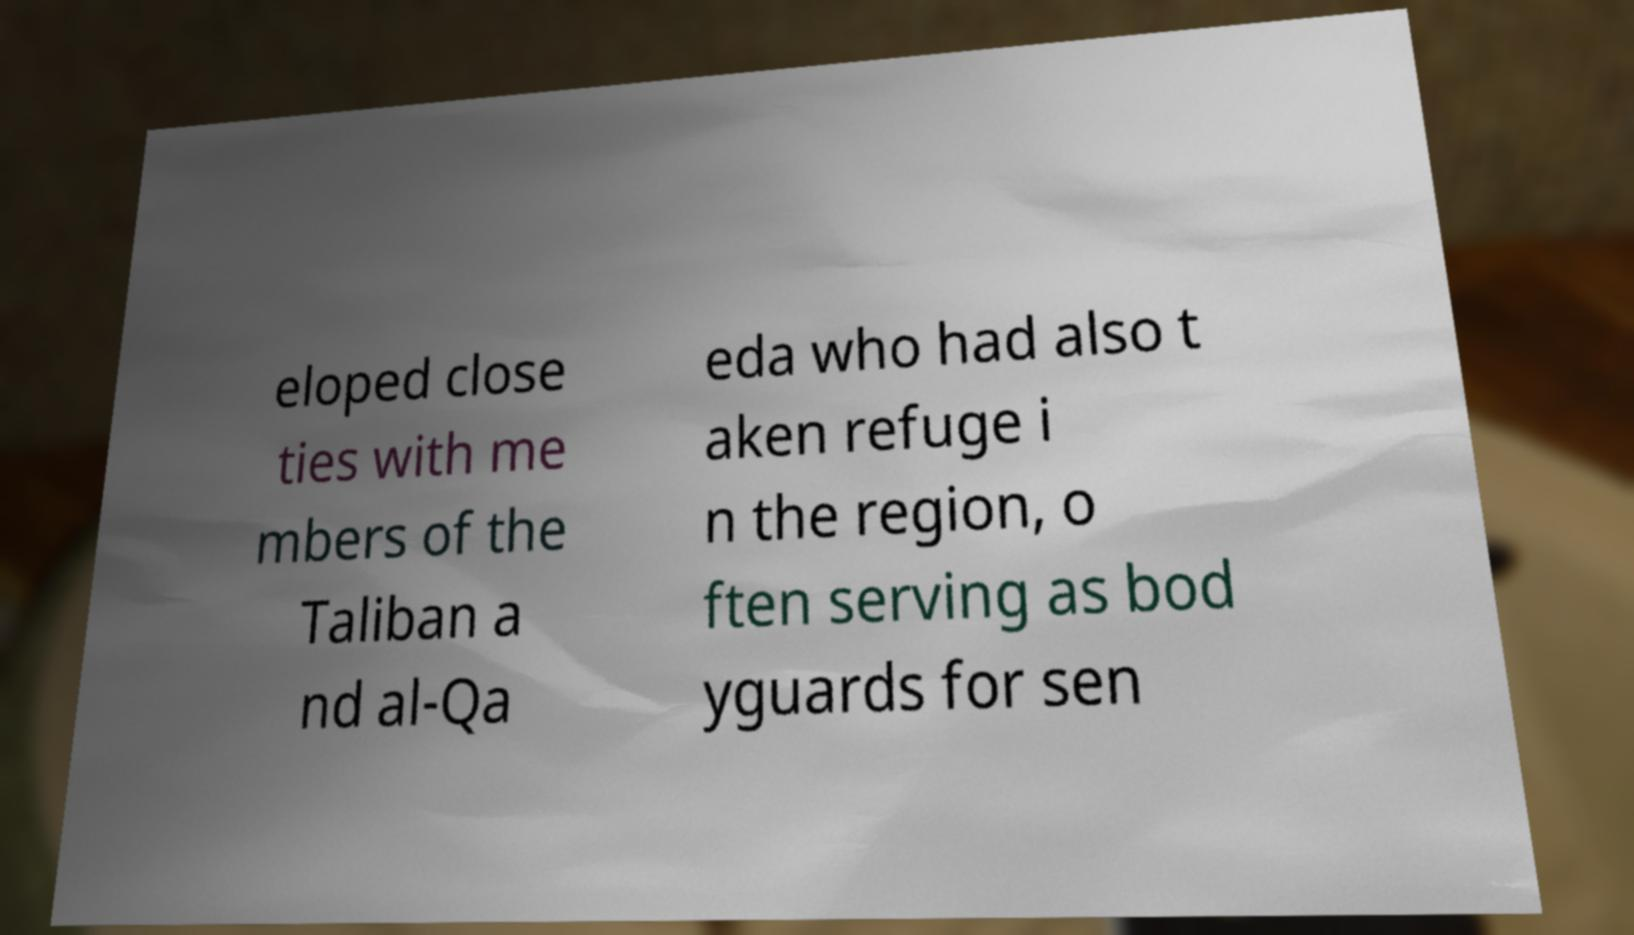What messages or text are displayed in this image? I need them in a readable, typed format. eloped close ties with me mbers of the Taliban a nd al-Qa eda who had also t aken refuge i n the region, o ften serving as bod yguards for sen 